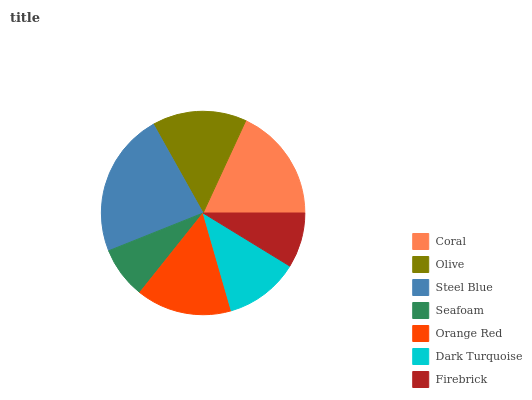Is Seafoam the minimum?
Answer yes or no. Yes. Is Steel Blue the maximum?
Answer yes or no. Yes. Is Olive the minimum?
Answer yes or no. No. Is Olive the maximum?
Answer yes or no. No. Is Coral greater than Olive?
Answer yes or no. Yes. Is Olive less than Coral?
Answer yes or no. Yes. Is Olive greater than Coral?
Answer yes or no. No. Is Coral less than Olive?
Answer yes or no. No. Is Olive the high median?
Answer yes or no. Yes. Is Olive the low median?
Answer yes or no. Yes. Is Coral the high median?
Answer yes or no. No. Is Orange Red the low median?
Answer yes or no. No. 